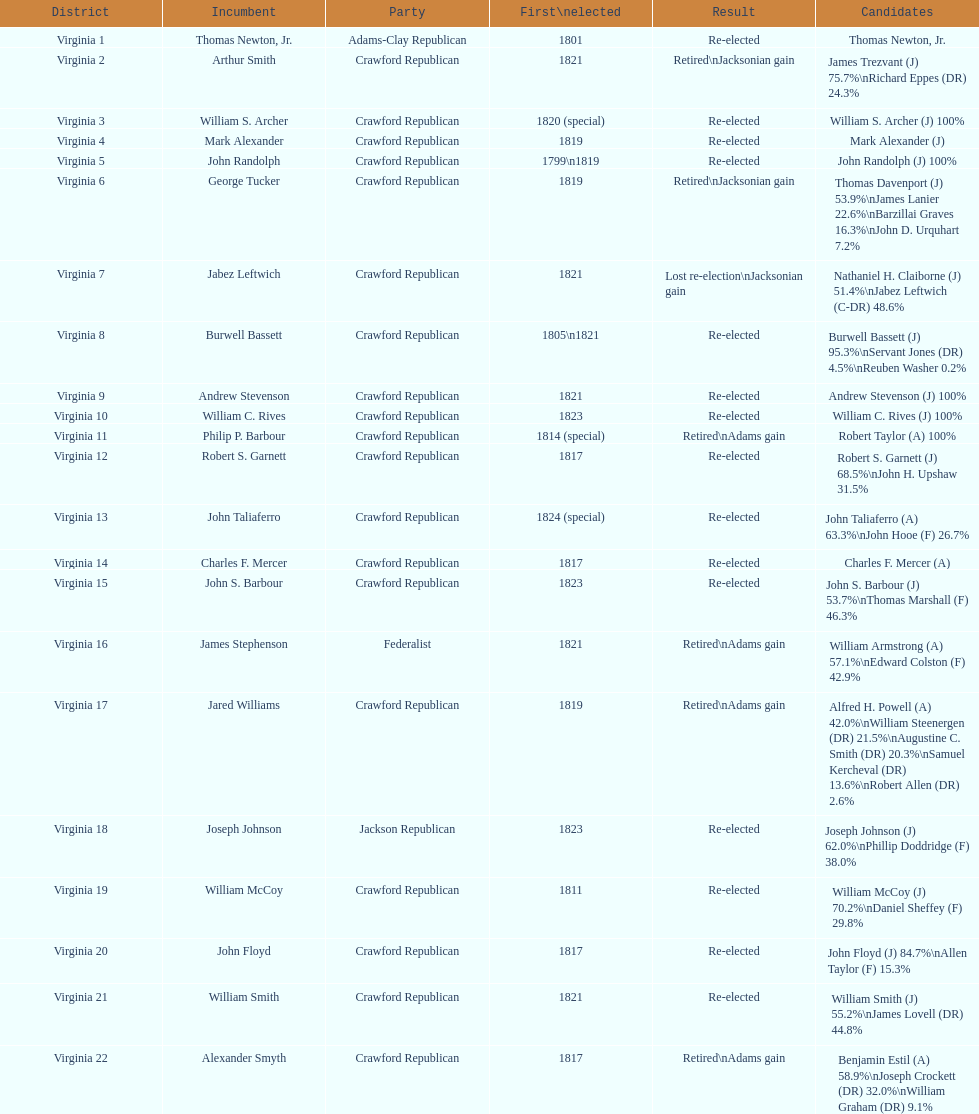Quantity of incumbents who retired or failed re-election 7. 